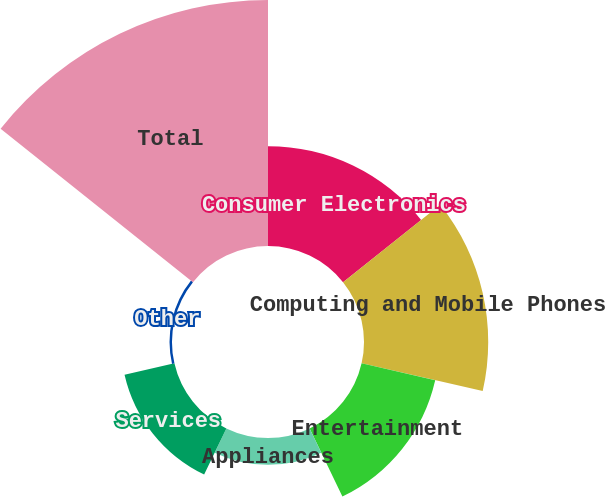<chart> <loc_0><loc_0><loc_500><loc_500><pie_chart><fcel>Consumer Electronics<fcel>Computing and Mobile Phones<fcel>Entertainment<fcel>Appliances<fcel>Services<fcel>Other<fcel>Total<nl><fcel>15.95%<fcel>19.84%<fcel>12.06%<fcel>4.28%<fcel>8.17%<fcel>0.39%<fcel>39.29%<nl></chart> 